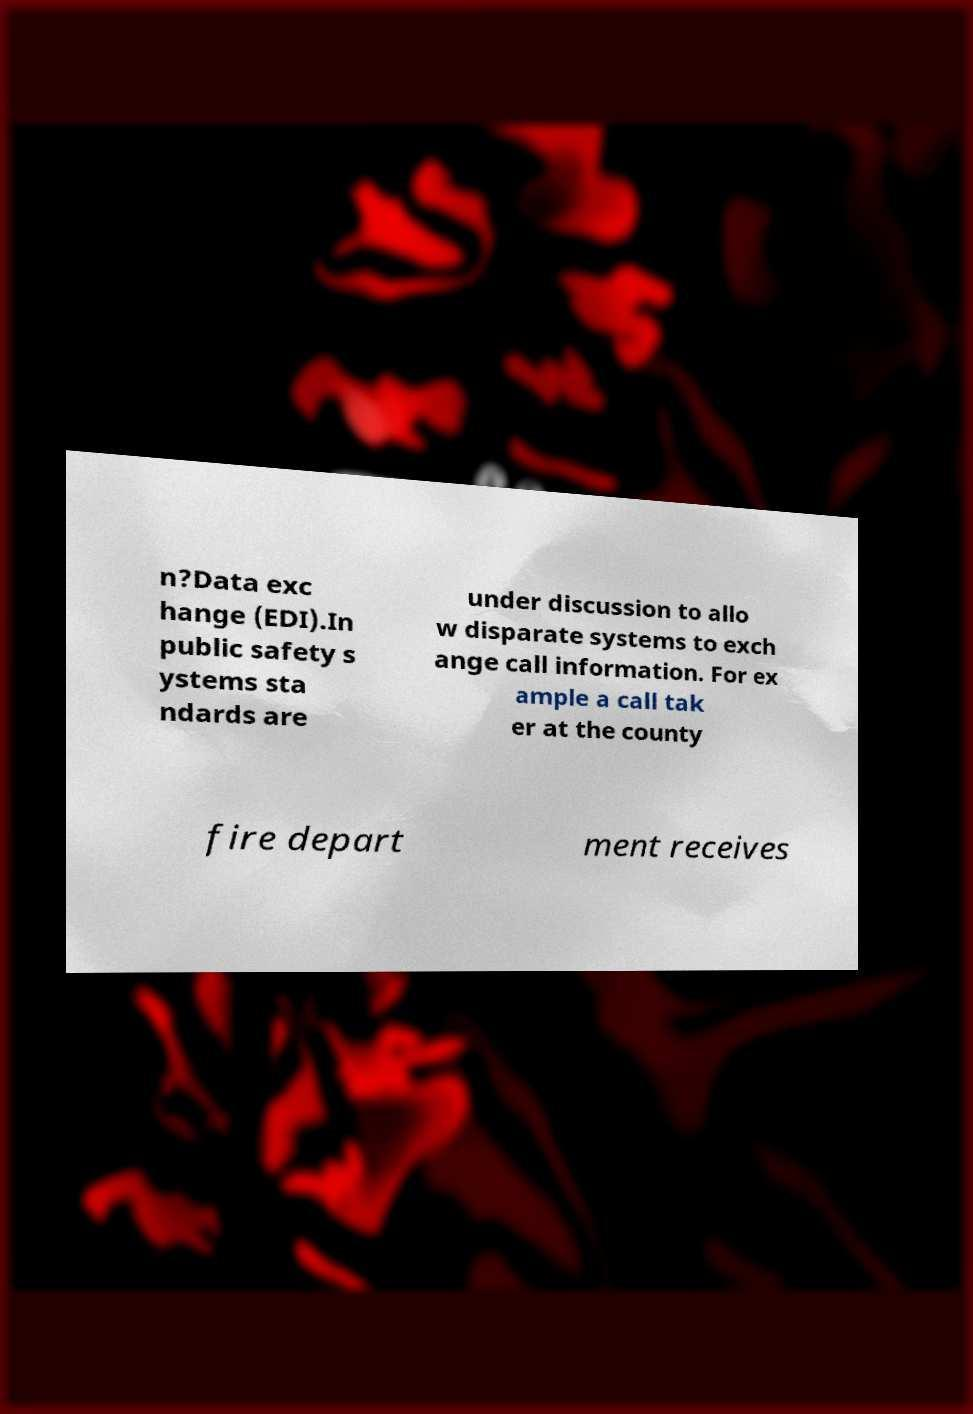There's text embedded in this image that I need extracted. Can you transcribe it verbatim? n?Data exc hange (EDI).In public safety s ystems sta ndards are under discussion to allo w disparate systems to exch ange call information. For ex ample a call tak er at the county fire depart ment receives 